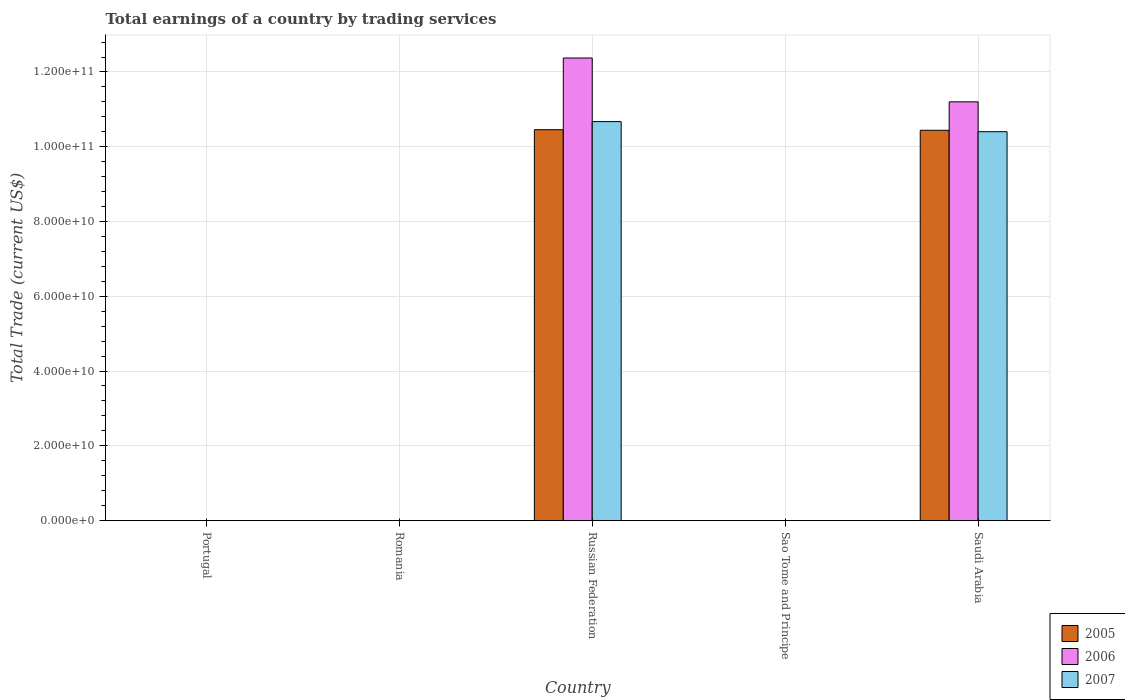Are the number of bars per tick equal to the number of legend labels?
Offer a terse response. No. Are the number of bars on each tick of the X-axis equal?
Offer a terse response. No. How many bars are there on the 5th tick from the left?
Provide a short and direct response. 3. What is the label of the 4th group of bars from the left?
Keep it short and to the point. Sao Tome and Principe. What is the total earnings in 2007 in Russian Federation?
Your answer should be compact. 1.07e+11. Across all countries, what is the maximum total earnings in 2007?
Provide a succinct answer. 1.07e+11. Across all countries, what is the minimum total earnings in 2005?
Offer a very short reply. 0. In which country was the total earnings in 2006 maximum?
Offer a terse response. Russian Federation. What is the total total earnings in 2006 in the graph?
Ensure brevity in your answer.  2.36e+11. What is the difference between the total earnings in 2005 in Russian Federation and the total earnings in 2007 in Romania?
Your answer should be very brief. 1.05e+11. What is the average total earnings in 2007 per country?
Offer a terse response. 4.22e+1. What is the difference between the total earnings of/in 2005 and total earnings of/in 2007 in Russian Federation?
Provide a short and direct response. -2.17e+09. What is the difference between the highest and the lowest total earnings in 2007?
Your answer should be compact. 1.07e+11. In how many countries, is the total earnings in 2007 greater than the average total earnings in 2007 taken over all countries?
Your response must be concise. 2. Is the sum of the total earnings in 2006 in Russian Federation and Saudi Arabia greater than the maximum total earnings in 2005 across all countries?
Keep it short and to the point. Yes. Is it the case that in every country, the sum of the total earnings in 2007 and total earnings in 2006 is greater than the total earnings in 2005?
Provide a succinct answer. No. How many bars are there?
Ensure brevity in your answer.  6. Are all the bars in the graph horizontal?
Offer a terse response. No. What is the difference between two consecutive major ticks on the Y-axis?
Your answer should be very brief. 2.00e+1. Are the values on the major ticks of Y-axis written in scientific E-notation?
Offer a very short reply. Yes. Does the graph contain any zero values?
Keep it short and to the point. Yes. Does the graph contain grids?
Your answer should be compact. Yes. Where does the legend appear in the graph?
Provide a succinct answer. Bottom right. How many legend labels are there?
Your response must be concise. 3. How are the legend labels stacked?
Offer a terse response. Vertical. What is the title of the graph?
Make the answer very short. Total earnings of a country by trading services. What is the label or title of the X-axis?
Give a very brief answer. Country. What is the label or title of the Y-axis?
Make the answer very short. Total Trade (current US$). What is the Total Trade (current US$) in 2006 in Portugal?
Provide a short and direct response. 0. What is the Total Trade (current US$) of 2007 in Portugal?
Give a very brief answer. 0. What is the Total Trade (current US$) in 2005 in Russian Federation?
Give a very brief answer. 1.05e+11. What is the Total Trade (current US$) in 2006 in Russian Federation?
Provide a succinct answer. 1.24e+11. What is the Total Trade (current US$) in 2007 in Russian Federation?
Offer a very short reply. 1.07e+11. What is the Total Trade (current US$) in 2005 in Sao Tome and Principe?
Your response must be concise. 0. What is the Total Trade (current US$) of 2005 in Saudi Arabia?
Provide a succinct answer. 1.04e+11. What is the Total Trade (current US$) of 2006 in Saudi Arabia?
Make the answer very short. 1.12e+11. What is the Total Trade (current US$) in 2007 in Saudi Arabia?
Provide a succinct answer. 1.04e+11. Across all countries, what is the maximum Total Trade (current US$) of 2005?
Your answer should be compact. 1.05e+11. Across all countries, what is the maximum Total Trade (current US$) in 2006?
Offer a terse response. 1.24e+11. Across all countries, what is the maximum Total Trade (current US$) of 2007?
Keep it short and to the point. 1.07e+11. Across all countries, what is the minimum Total Trade (current US$) of 2006?
Ensure brevity in your answer.  0. What is the total Total Trade (current US$) in 2005 in the graph?
Ensure brevity in your answer.  2.09e+11. What is the total Total Trade (current US$) of 2006 in the graph?
Your answer should be very brief. 2.36e+11. What is the total Total Trade (current US$) in 2007 in the graph?
Keep it short and to the point. 2.11e+11. What is the difference between the Total Trade (current US$) of 2005 in Russian Federation and that in Saudi Arabia?
Provide a short and direct response. 1.54e+08. What is the difference between the Total Trade (current US$) in 2006 in Russian Federation and that in Saudi Arabia?
Your response must be concise. 1.17e+1. What is the difference between the Total Trade (current US$) in 2007 in Russian Federation and that in Saudi Arabia?
Your response must be concise. 2.70e+09. What is the difference between the Total Trade (current US$) of 2005 in Russian Federation and the Total Trade (current US$) of 2006 in Saudi Arabia?
Keep it short and to the point. -7.45e+09. What is the difference between the Total Trade (current US$) in 2005 in Russian Federation and the Total Trade (current US$) in 2007 in Saudi Arabia?
Keep it short and to the point. 5.34e+08. What is the difference between the Total Trade (current US$) in 2006 in Russian Federation and the Total Trade (current US$) in 2007 in Saudi Arabia?
Offer a terse response. 1.97e+1. What is the average Total Trade (current US$) of 2005 per country?
Provide a succinct answer. 4.18e+1. What is the average Total Trade (current US$) of 2006 per country?
Offer a very short reply. 4.72e+1. What is the average Total Trade (current US$) in 2007 per country?
Ensure brevity in your answer.  4.22e+1. What is the difference between the Total Trade (current US$) in 2005 and Total Trade (current US$) in 2006 in Russian Federation?
Your answer should be very brief. -1.92e+1. What is the difference between the Total Trade (current US$) of 2005 and Total Trade (current US$) of 2007 in Russian Federation?
Provide a short and direct response. -2.17e+09. What is the difference between the Total Trade (current US$) in 2006 and Total Trade (current US$) in 2007 in Russian Federation?
Your response must be concise. 1.70e+1. What is the difference between the Total Trade (current US$) in 2005 and Total Trade (current US$) in 2006 in Saudi Arabia?
Provide a succinct answer. -7.61e+09. What is the difference between the Total Trade (current US$) of 2005 and Total Trade (current US$) of 2007 in Saudi Arabia?
Your answer should be compact. 3.80e+08. What is the difference between the Total Trade (current US$) in 2006 and Total Trade (current US$) in 2007 in Saudi Arabia?
Provide a succinct answer. 7.99e+09. What is the ratio of the Total Trade (current US$) of 2005 in Russian Federation to that in Saudi Arabia?
Ensure brevity in your answer.  1. What is the ratio of the Total Trade (current US$) in 2006 in Russian Federation to that in Saudi Arabia?
Your answer should be very brief. 1.1. What is the difference between the highest and the lowest Total Trade (current US$) in 2005?
Your answer should be very brief. 1.05e+11. What is the difference between the highest and the lowest Total Trade (current US$) in 2006?
Make the answer very short. 1.24e+11. What is the difference between the highest and the lowest Total Trade (current US$) of 2007?
Make the answer very short. 1.07e+11. 